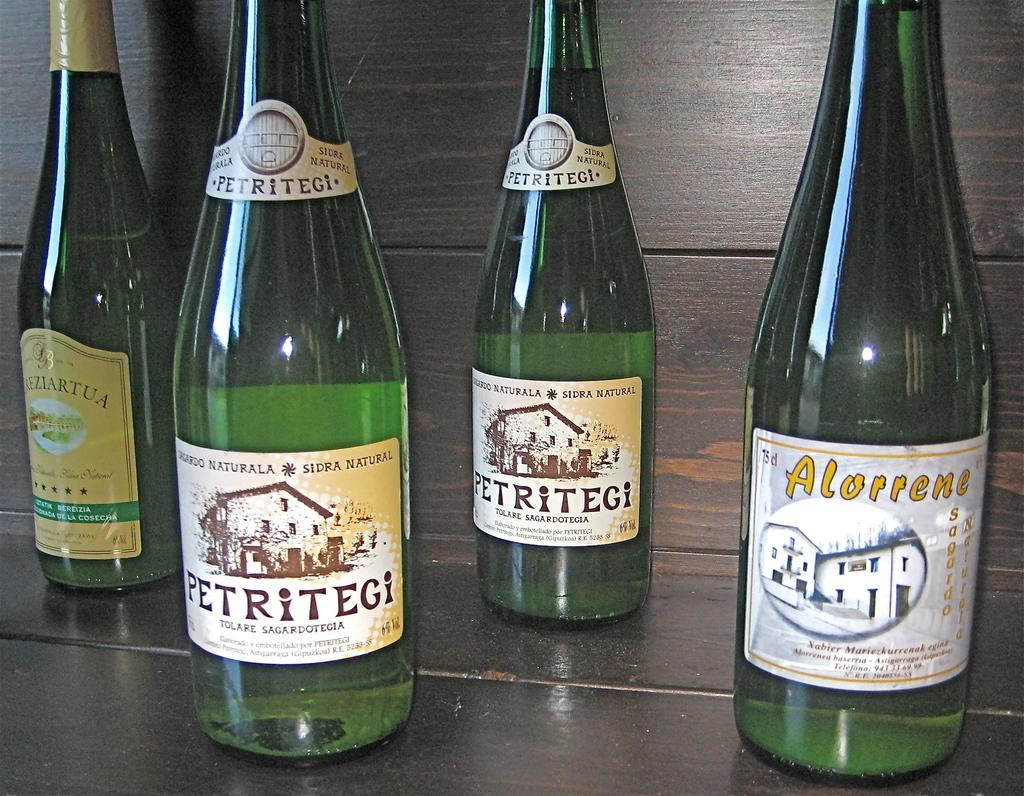<image>
Describe the image concisely. A group of four green wine bottles on a wood table. 